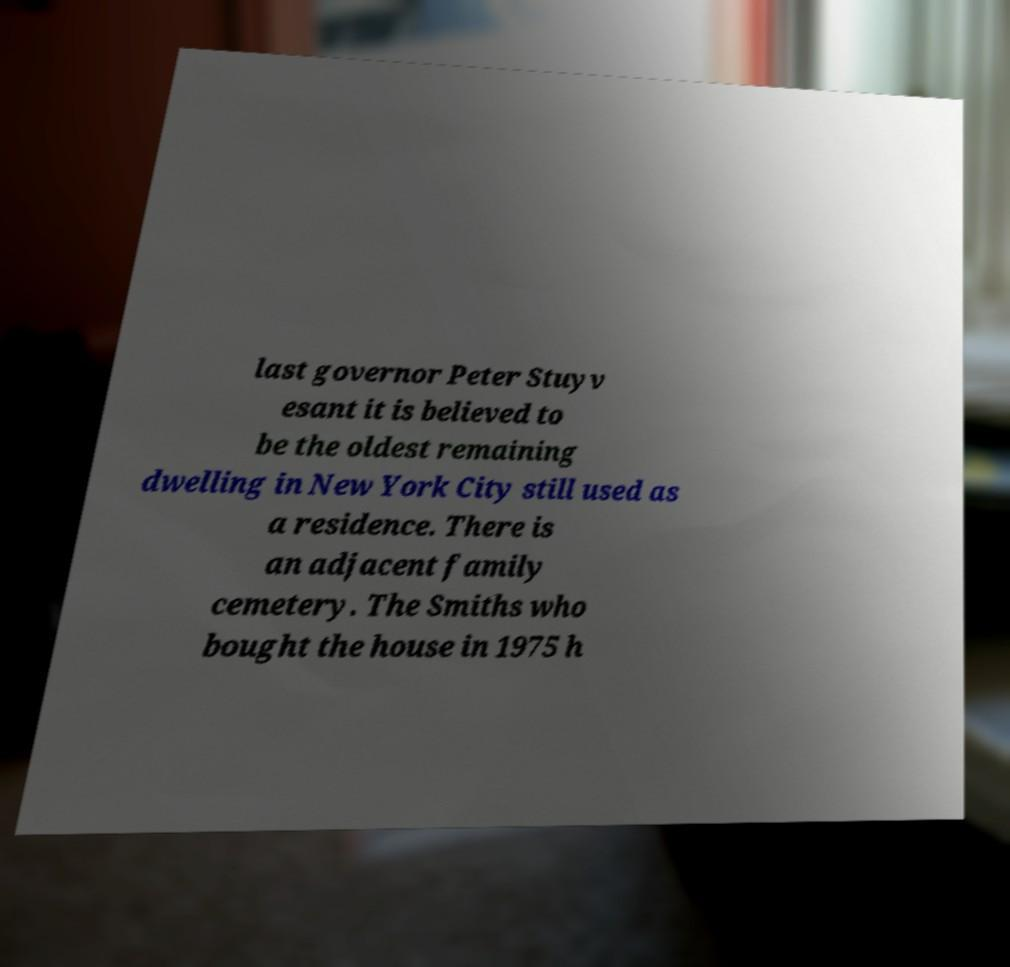Could you extract and type out the text from this image? last governor Peter Stuyv esant it is believed to be the oldest remaining dwelling in New York City still used as a residence. There is an adjacent family cemetery. The Smiths who bought the house in 1975 h 